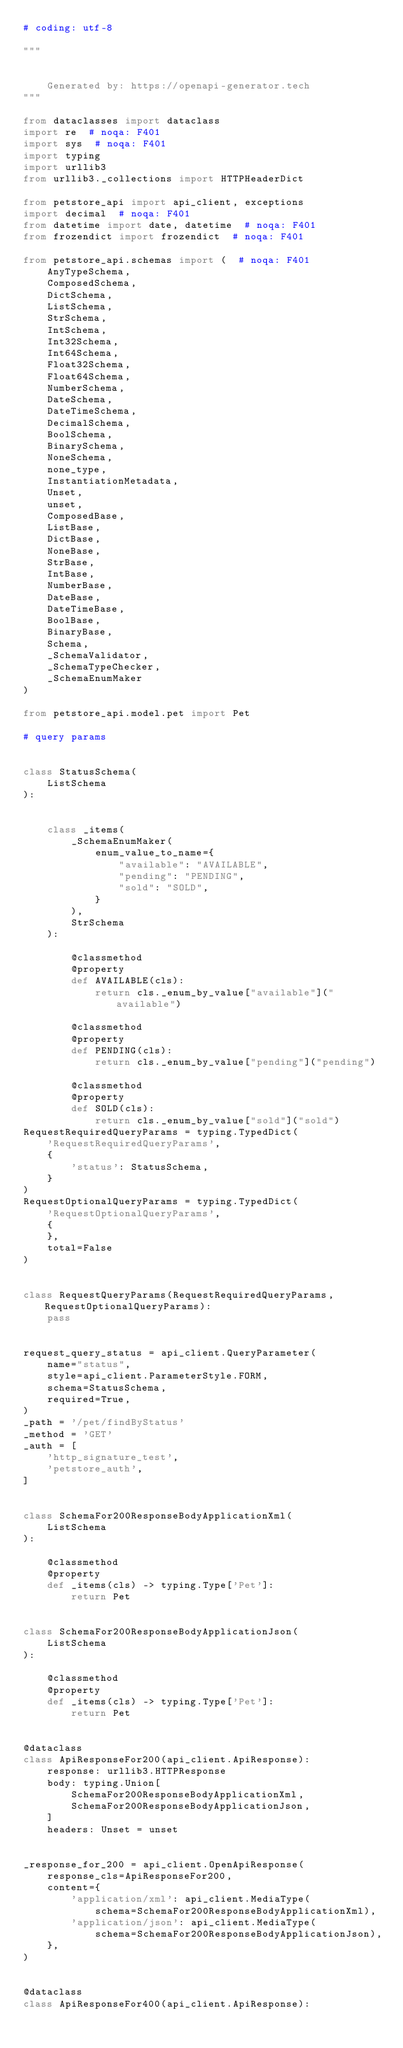Convert code to text. <code><loc_0><loc_0><loc_500><loc_500><_Python_># coding: utf-8

"""


    Generated by: https://openapi-generator.tech
"""

from dataclasses import dataclass
import re  # noqa: F401
import sys  # noqa: F401
import typing
import urllib3
from urllib3._collections import HTTPHeaderDict

from petstore_api import api_client, exceptions
import decimal  # noqa: F401
from datetime import date, datetime  # noqa: F401
from frozendict import frozendict  # noqa: F401

from petstore_api.schemas import (  # noqa: F401
    AnyTypeSchema,
    ComposedSchema,
    DictSchema,
    ListSchema,
    StrSchema,
    IntSchema,
    Int32Schema,
    Int64Schema,
    Float32Schema,
    Float64Schema,
    NumberSchema,
    DateSchema,
    DateTimeSchema,
    DecimalSchema,
    BoolSchema,
    BinarySchema,
    NoneSchema,
    none_type,
    InstantiationMetadata,
    Unset,
    unset,
    ComposedBase,
    ListBase,
    DictBase,
    NoneBase,
    StrBase,
    IntBase,
    NumberBase,
    DateBase,
    DateTimeBase,
    BoolBase,
    BinaryBase,
    Schema,
    _SchemaValidator,
    _SchemaTypeChecker,
    _SchemaEnumMaker
)

from petstore_api.model.pet import Pet

# query params


class StatusSchema(
    ListSchema
):
    
    
    class _items(
        _SchemaEnumMaker(
            enum_value_to_name={
                "available": "AVAILABLE",
                "pending": "PENDING",
                "sold": "SOLD",
            }
        ),
        StrSchema
    ):
        
        @classmethod
        @property
        def AVAILABLE(cls):
            return cls._enum_by_value["available"]("available")
        
        @classmethod
        @property
        def PENDING(cls):
            return cls._enum_by_value["pending"]("pending")
        
        @classmethod
        @property
        def SOLD(cls):
            return cls._enum_by_value["sold"]("sold")
RequestRequiredQueryParams = typing.TypedDict(
    'RequestRequiredQueryParams',
    {
        'status': StatusSchema,
    }
)
RequestOptionalQueryParams = typing.TypedDict(
    'RequestOptionalQueryParams',
    {
    },
    total=False
)


class RequestQueryParams(RequestRequiredQueryParams, RequestOptionalQueryParams):
    pass


request_query_status = api_client.QueryParameter(
    name="status",
    style=api_client.ParameterStyle.FORM,
    schema=StatusSchema,
    required=True,
)
_path = '/pet/findByStatus'
_method = 'GET'
_auth = [
    'http_signature_test',
    'petstore_auth',
]


class SchemaFor200ResponseBodyApplicationXml(
    ListSchema
):

    @classmethod
    @property
    def _items(cls) -> typing.Type['Pet']:
        return Pet


class SchemaFor200ResponseBodyApplicationJson(
    ListSchema
):

    @classmethod
    @property
    def _items(cls) -> typing.Type['Pet']:
        return Pet


@dataclass
class ApiResponseFor200(api_client.ApiResponse):
    response: urllib3.HTTPResponse
    body: typing.Union[
        SchemaFor200ResponseBodyApplicationXml,
        SchemaFor200ResponseBodyApplicationJson,
    ]
    headers: Unset = unset


_response_for_200 = api_client.OpenApiResponse(
    response_cls=ApiResponseFor200,
    content={
        'application/xml': api_client.MediaType(
            schema=SchemaFor200ResponseBodyApplicationXml),
        'application/json': api_client.MediaType(
            schema=SchemaFor200ResponseBodyApplicationJson),
    },
)


@dataclass
class ApiResponseFor400(api_client.ApiResponse):</code> 